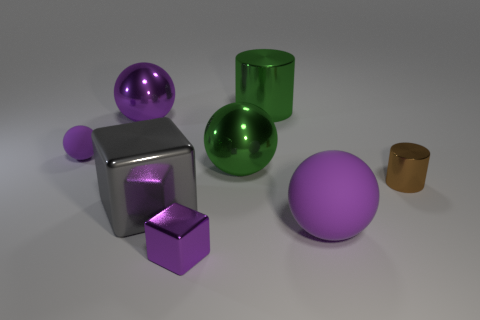How many purple spheres must be subtracted to get 1 purple spheres? 2 Subtract all yellow cylinders. How many purple spheres are left? 3 Add 1 big green metal balls. How many objects exist? 9 Subtract all cylinders. How many objects are left? 6 Add 5 tiny matte things. How many tiny matte things are left? 6 Add 6 small brown things. How many small brown things exist? 7 Subtract 1 green spheres. How many objects are left? 7 Subtract all small matte blocks. Subtract all large shiny things. How many objects are left? 4 